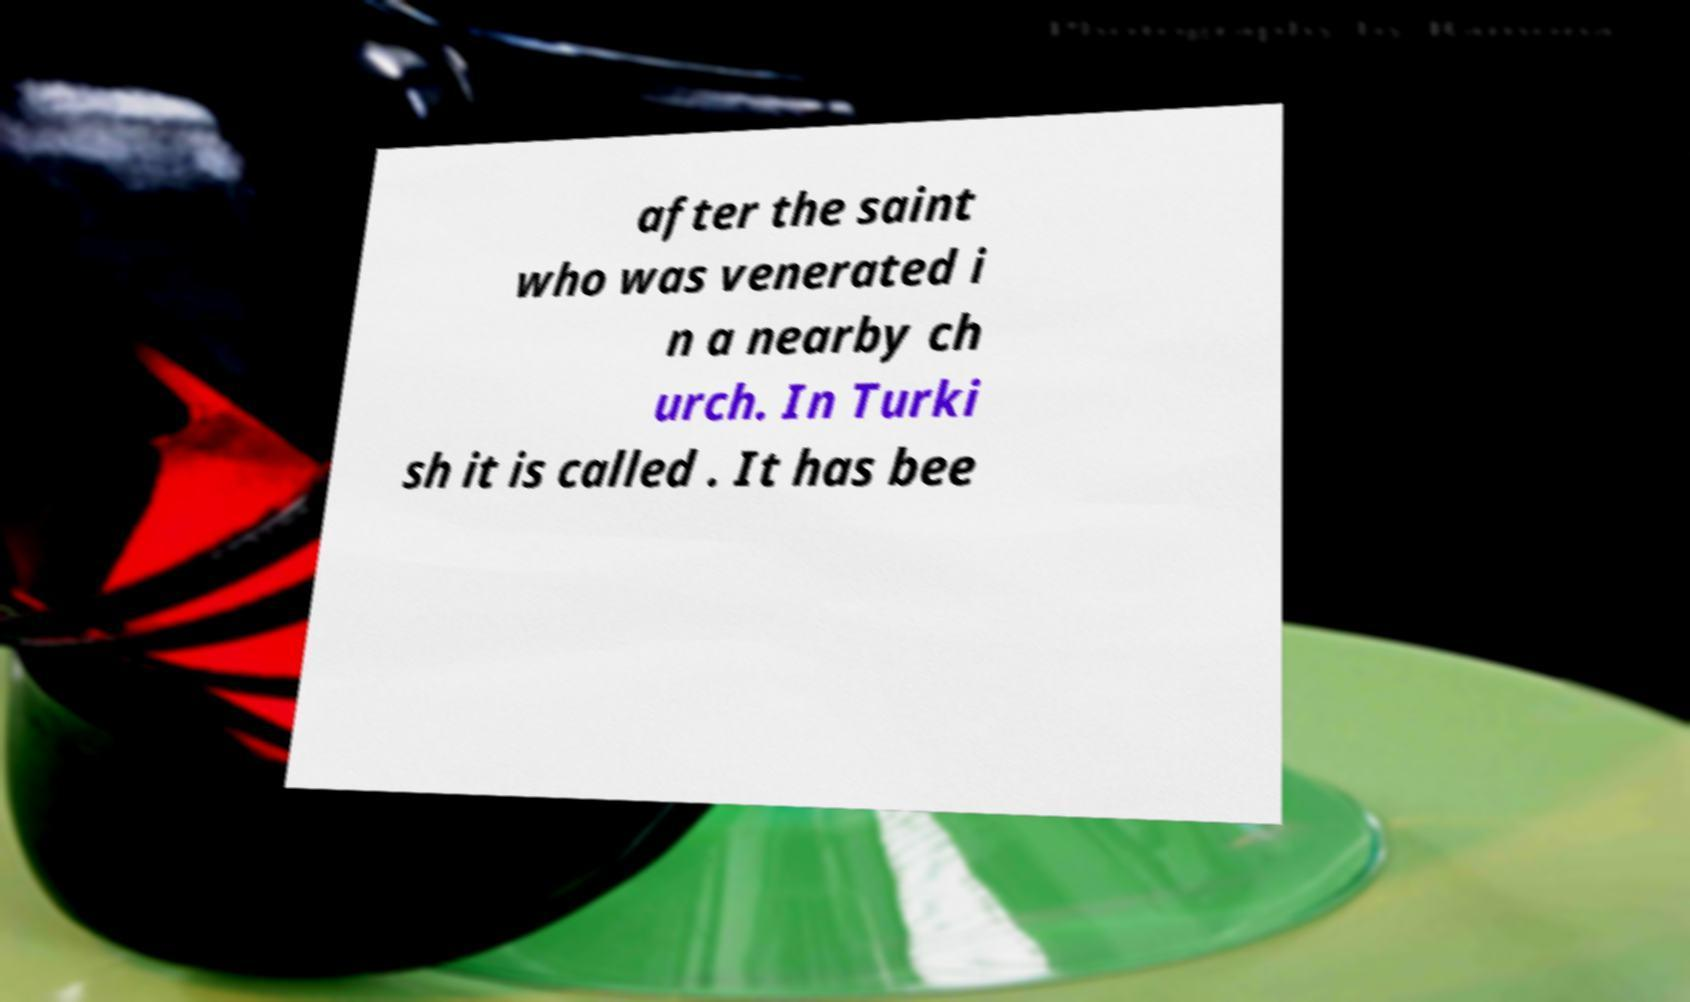Can you read and provide the text displayed in the image?This photo seems to have some interesting text. Can you extract and type it out for me? after the saint who was venerated i n a nearby ch urch. In Turki sh it is called . It has bee 